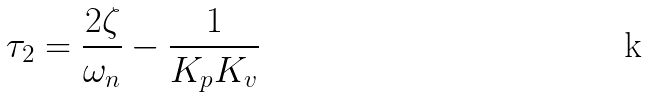<formula> <loc_0><loc_0><loc_500><loc_500>\tau _ { 2 } = \frac { 2 \zeta } { \omega _ { n } } - \frac { 1 } { K _ { p } K _ { v } }</formula> 